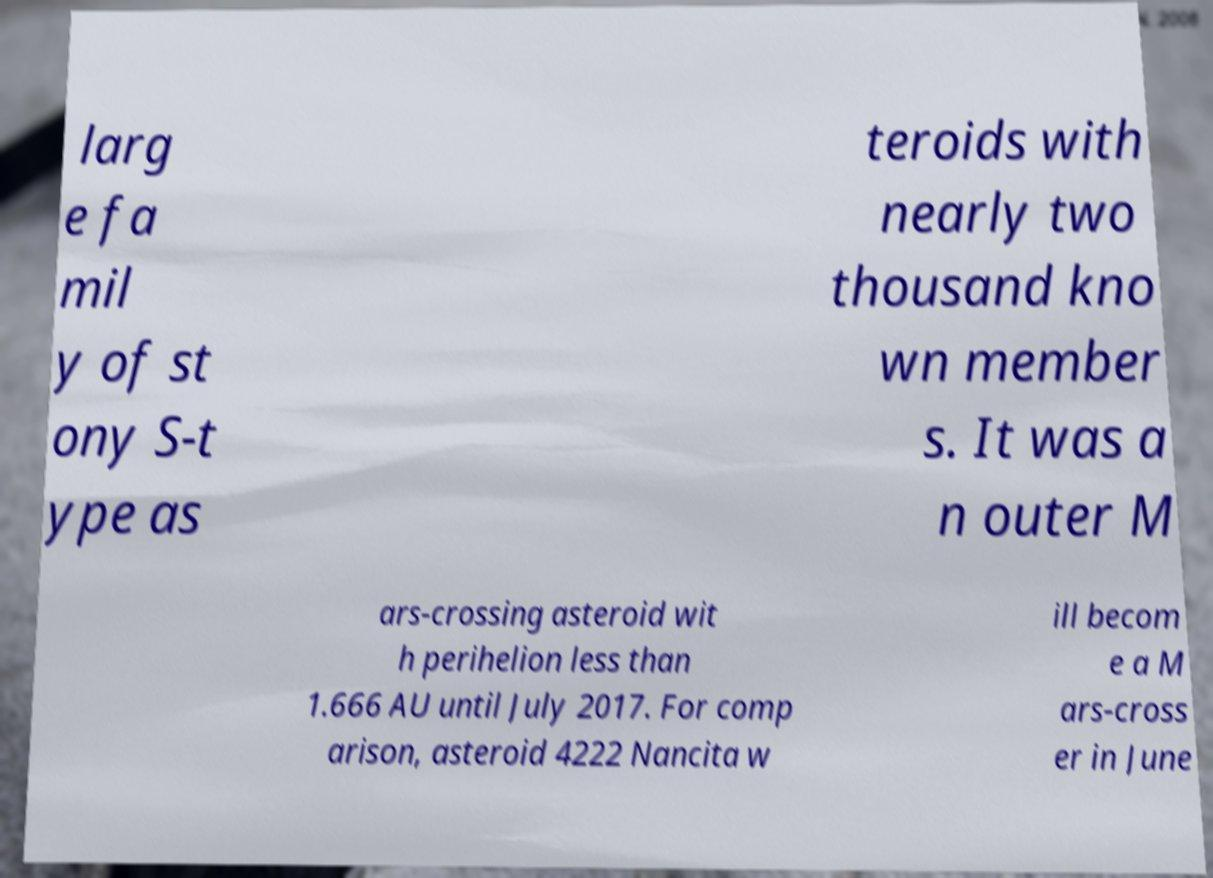Could you assist in decoding the text presented in this image and type it out clearly? larg e fa mil y of st ony S-t ype as teroids with nearly two thousand kno wn member s. It was a n outer M ars-crossing asteroid wit h perihelion less than 1.666 AU until July 2017. For comp arison, asteroid 4222 Nancita w ill becom e a M ars-cross er in June 